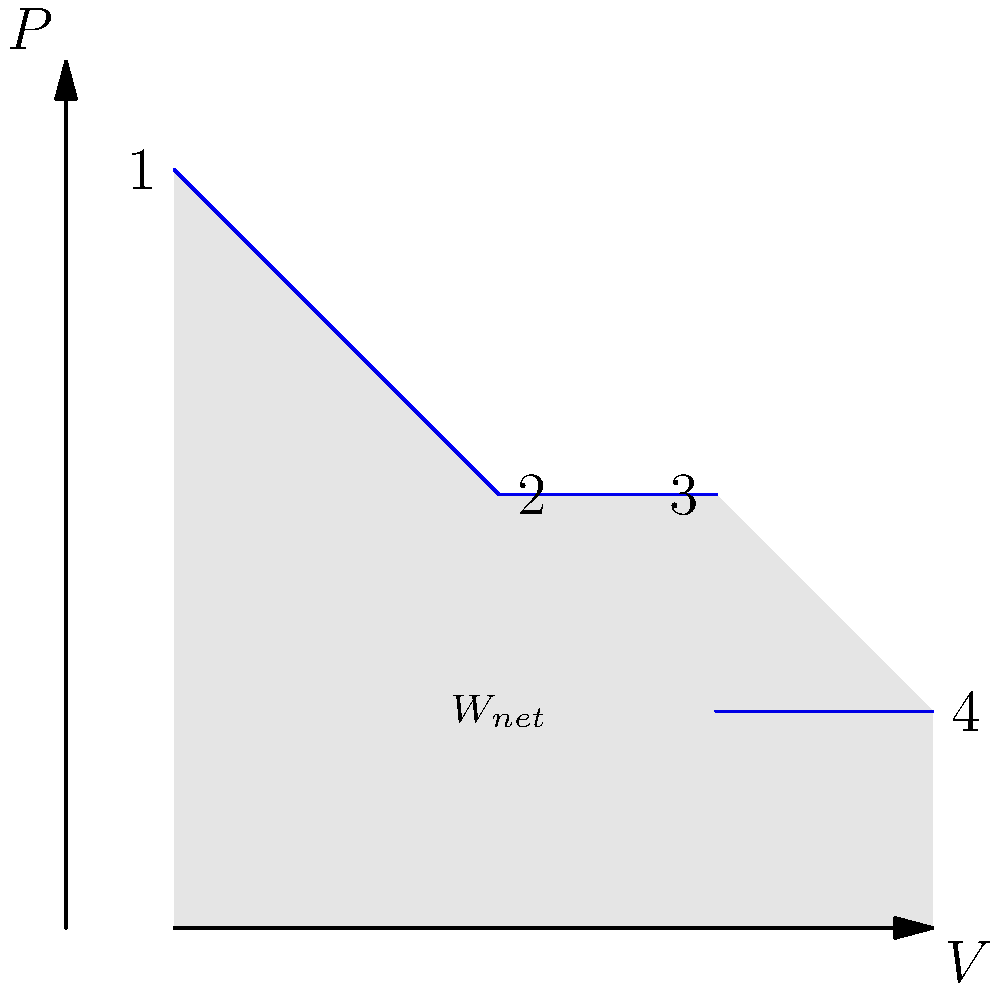In the pressure-volume (P-V) diagram shown, a heat engine undergoes a cyclic process 1-2-3-4-1. If the temperature at state 1 is 600 K and at state 3 is 400 K, calculate the efficiency of this heat engine. Assume the working fluid is an ideal gas. To calculate the efficiency of the heat engine, we'll follow these steps:

1) The efficiency of a heat engine is given by:
   $$\eta = 1 - \frac{T_C}{T_H}$$
   where $T_C$ is the cold reservoir temperature and $T_H$ is the hot reservoir temperature.

2) From the given information:
   $T_H = 600$ K (at state 1)
   $T_C = 400$ K (at state 3)

3) Substituting these values into the efficiency formula:
   $$\eta = 1 - \frac{400 \text{ K}}{600 \text{ K}}$$

4) Simplifying:
   $$\eta = 1 - \frac{2}{3} = \frac{1}{3}$$

5) Converting to a percentage:
   $$\eta = \frac{1}{3} \times 100\% = 33.33\%$$

Therefore, the efficiency of the heat engine is approximately 33.33%.

Note: This calculation assumes that the engine operates between two thermal reservoirs at the given temperatures. The actual cycle efficiency might be lower due to irreversibilities, but this theoretical maximum is based on the given temperatures.
Answer: 33.33% 